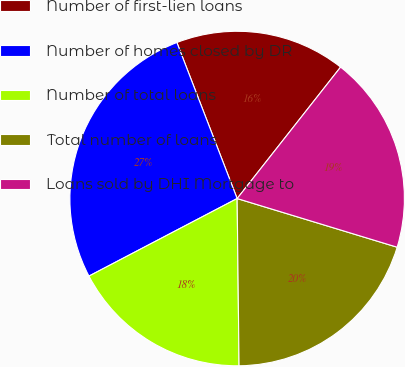<chart> <loc_0><loc_0><loc_500><loc_500><pie_chart><fcel>Number of first-lien loans<fcel>Number of homes closed by DR<fcel>Number of total loans<fcel>Total number of loans<fcel>Loans sold by DHI Mortgage to<nl><fcel>16.48%<fcel>26.81%<fcel>17.51%<fcel>20.12%<fcel>19.09%<nl></chart> 